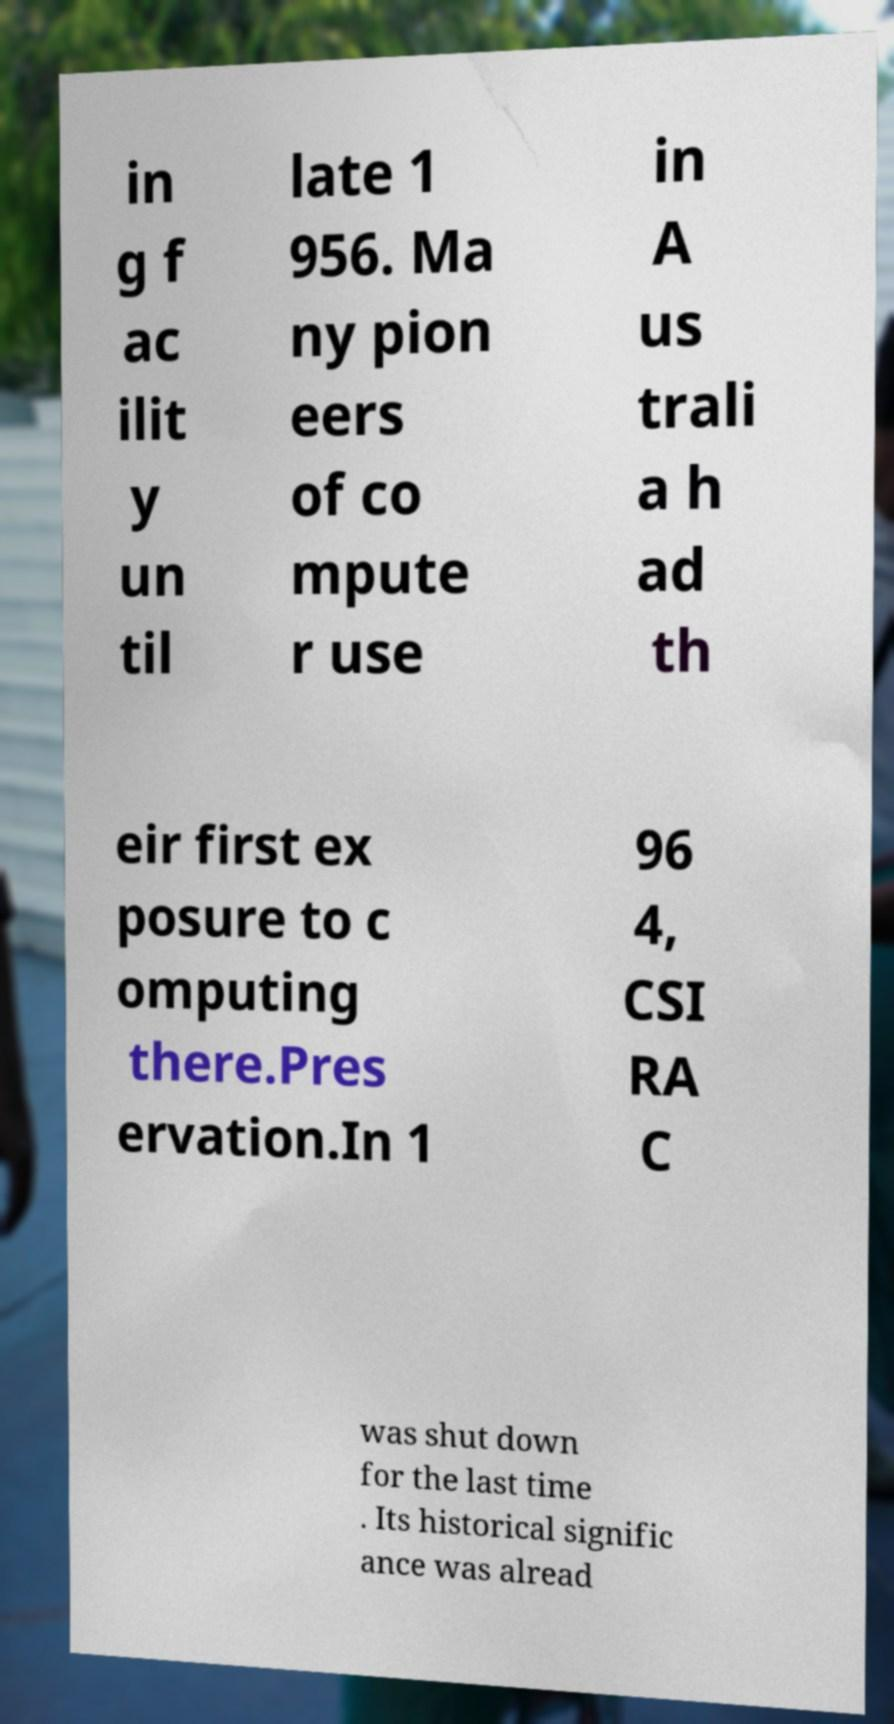I need the written content from this picture converted into text. Can you do that? in g f ac ilit y un til late 1 956. Ma ny pion eers of co mpute r use in A us trali a h ad th eir first ex posure to c omputing there.Pres ervation.In 1 96 4, CSI RA C was shut down for the last time . Its historical signific ance was alread 